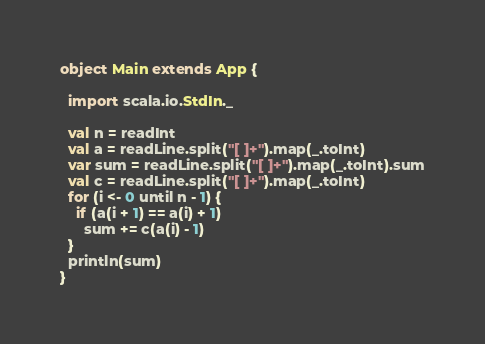Convert code to text. <code><loc_0><loc_0><loc_500><loc_500><_Scala_>object Main extends App {

  import scala.io.StdIn._

  val n = readInt
  val a = readLine.split("[ ]+").map(_.toInt)
  var sum = readLine.split("[ ]+").map(_.toInt).sum
  val c = readLine.split("[ ]+").map(_.toInt)
  for (i <- 0 until n - 1) {
    if (a(i + 1) == a(i) + 1)
      sum += c(a(i) - 1)
  }
  println(sum)
}
</code> 